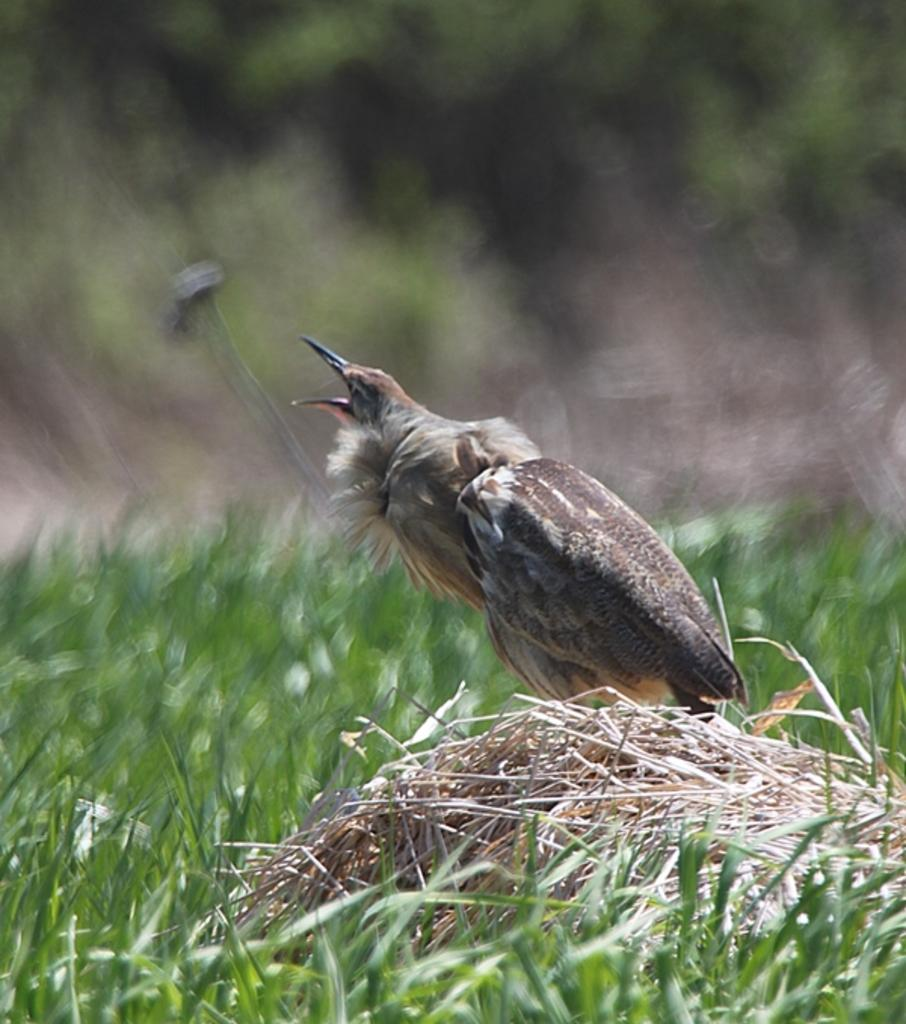What type of animal is present in the image? There is a bird in the image. What is the bird standing on? The bird is standing on dry grass. What color is the grass surrounding the dry grass? The grass surrounding the dry grass is green. What color is the background of the image? The background of the image is blue. What type of roof can be seen on the bird in the image? A: There is no roof present on the bird in the image, as birds do not have roofs. What type of bird is the robin in the image? There is no robin present in the image, only a bird is mentioned. 